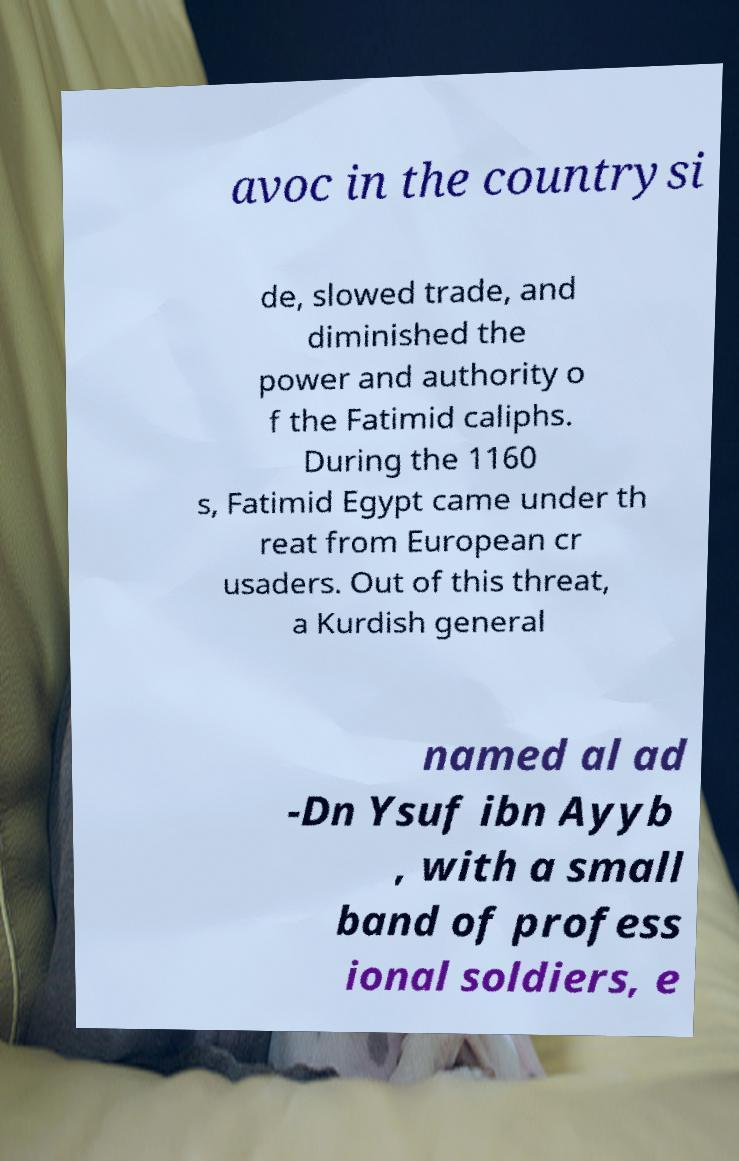Can you accurately transcribe the text from the provided image for me? avoc in the countrysi de, slowed trade, and diminished the power and authority o f the Fatimid caliphs. During the 1160 s, Fatimid Egypt came under th reat from European cr usaders. Out of this threat, a Kurdish general named al ad -Dn Ysuf ibn Ayyb , with a small band of profess ional soldiers, e 